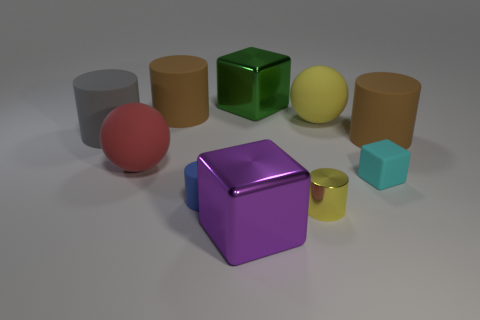Is the material of the large purple object the same as the yellow cylinder on the right side of the gray thing?
Your answer should be compact. Yes. There is a yellow thing that is made of the same material as the big red thing; what is its size?
Your response must be concise. Large. Is the number of small cyan rubber cubes that are in front of the yellow rubber ball greater than the number of purple cubes that are behind the big green metallic cube?
Your answer should be compact. Yes. Is there a yellow object that has the same shape as the big gray thing?
Provide a succinct answer. Yes. Does the brown thing that is to the right of the cyan rubber thing have the same size as the green cube?
Make the answer very short. Yes. Are there any tiny green rubber blocks?
Ensure brevity in your answer.  No. What number of things are big things that are on the right side of the red rubber sphere or small blue things?
Your response must be concise. 6. There is a small shiny cylinder; is its color the same as the thing that is to the right of the small cyan thing?
Your answer should be very brief. No. Are there any purple cubes that have the same size as the green shiny thing?
Offer a terse response. Yes. What material is the brown cylinder to the right of the big metal block in front of the red ball?
Provide a short and direct response. Rubber. 